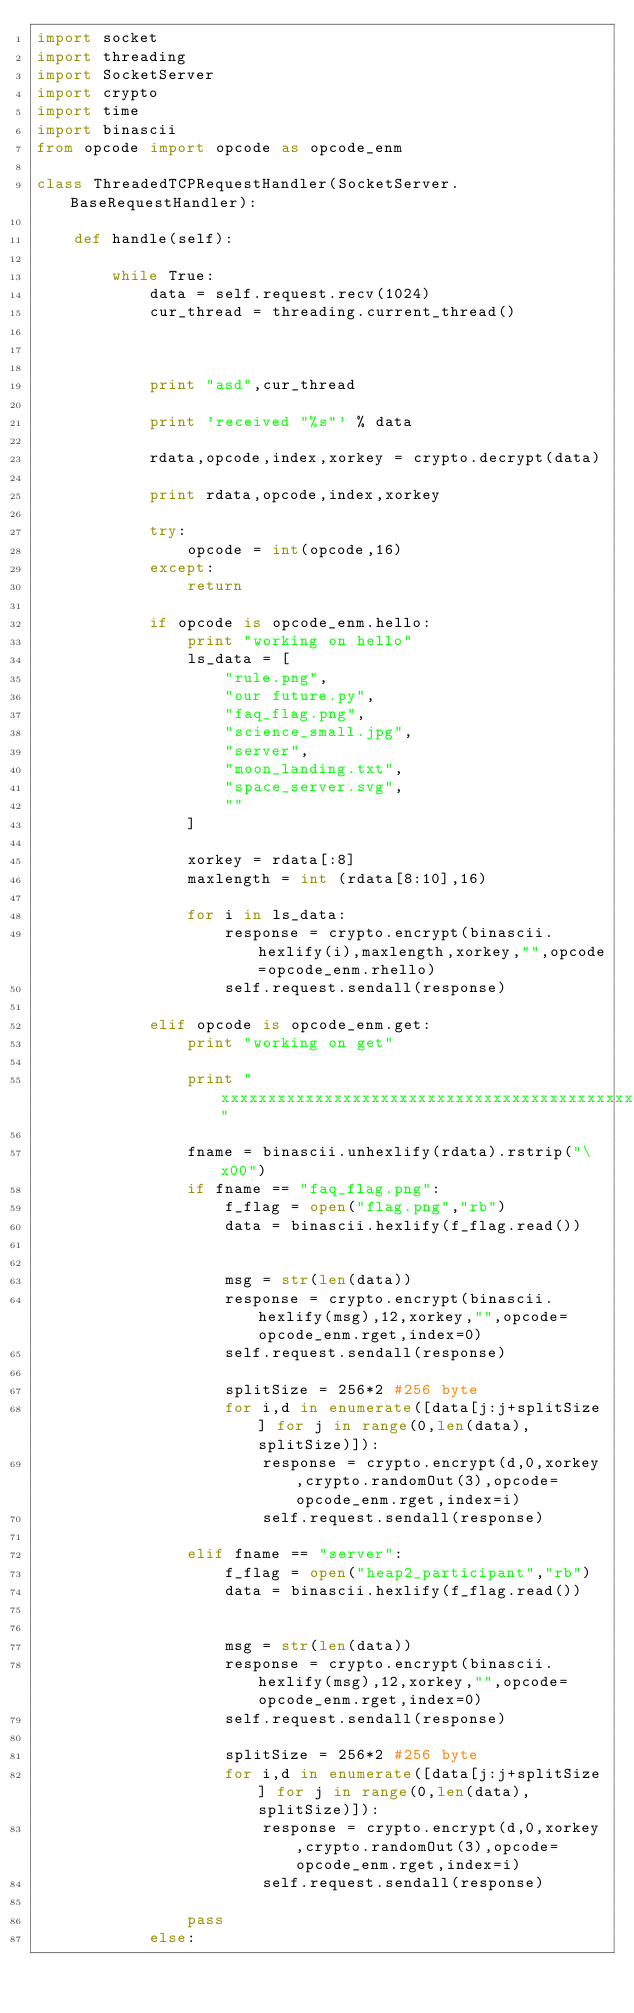Convert code to text. <code><loc_0><loc_0><loc_500><loc_500><_Python_>import socket
import threading
import SocketServer
import crypto
import time
import binascii
from opcode import opcode as opcode_enm

class ThreadedTCPRequestHandler(SocketServer.BaseRequestHandler):

	def handle(self):

		while True:
			data = self.request.recv(1024)
			cur_thread = threading.current_thread()



			print "asd",cur_thread

			print 'received "%s"' % data

			rdata,opcode,index,xorkey = crypto.decrypt(data)

			print rdata,opcode,index,xorkey

			try:
				opcode = int(opcode,16)
			except:
				return

			if opcode is opcode_enm.hello:
				print "working on hello"
				ls_data = [
					"rule.png",
					"our future.py",
					"faq_flag.png",
					"science_small.jpg",
					"server",
					"moon_landing.txt",
					"space_server.svg",
					""
				]

				xorkey = rdata[:8]
				maxlength = int (rdata[8:10],16)

				for i in ls_data:
					response = crypto.encrypt(binascii.hexlify(i),maxlength,xorkey,"",opcode=opcode_enm.rhello)
					self.request.sendall(response)

			elif opcode is opcode_enm.get:
				print "working on get"

				print "xxxxxxxxxxxxxxxxxxxxxxxxxxxxxxxxxxxxxxxxxxxxxxxx"

				fname = binascii.unhexlify(rdata).rstrip("\x00")
				if fname == "faq_flag.png":
					f_flag = open("flag.png","rb")
					data = binascii.hexlify(f_flag.read())


					msg = str(len(data))
					response = crypto.encrypt(binascii.hexlify(msg),12,xorkey,"",opcode=opcode_enm.rget,index=0)
					self.request.sendall(response)

					splitSize = 256*2 #256 byte
					for i,d in enumerate([data[j:j+splitSize] for j in range(0,len(data),splitSize)]):
						response = crypto.encrypt(d,0,xorkey,crypto.randomOut(3),opcode=opcode_enm.rget,index=i)
						self.request.sendall(response)
				
				elif fname == "server":
					f_flag = open("heap2_participant","rb")
					data = binascii.hexlify(f_flag.read())


					msg = str(len(data))
					response = crypto.encrypt(binascii.hexlify(msg),12,xorkey,"",opcode=opcode_enm.rget,index=0)
					self.request.sendall(response)

					splitSize = 256*2 #256 byte
					for i,d in enumerate([data[j:j+splitSize] for j in range(0,len(data),splitSize)]):
						response = crypto.encrypt(d,0,xorkey,crypto.randomOut(3),opcode=opcode_enm.rget,index=i)
						self.request.sendall(response)

				pass
			else:</code> 